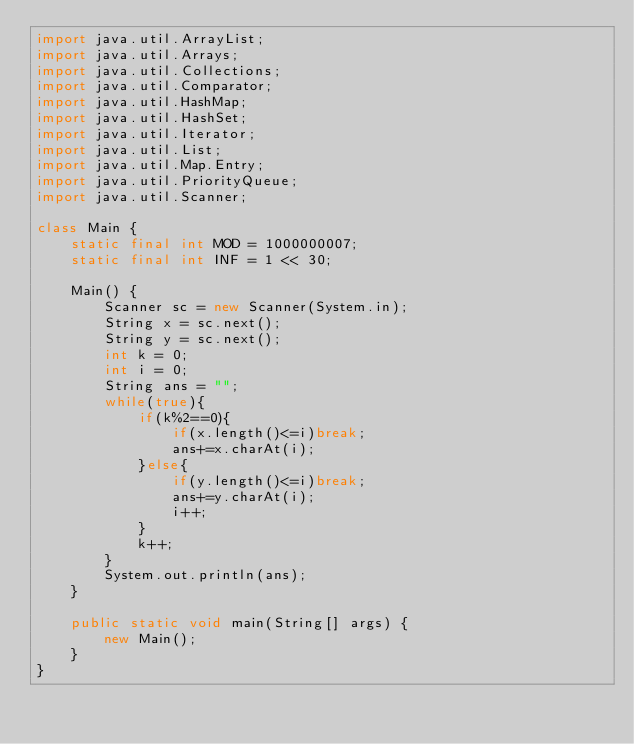Convert code to text. <code><loc_0><loc_0><loc_500><loc_500><_Java_>import java.util.ArrayList;
import java.util.Arrays;
import java.util.Collections;
import java.util.Comparator;
import java.util.HashMap;
import java.util.HashSet;
import java.util.Iterator;
import java.util.List;
import java.util.Map.Entry;
import java.util.PriorityQueue;
import java.util.Scanner;

class Main {
    static final int MOD = 1000000007;
    static final int INF = 1 << 30;

    Main() {
        Scanner sc = new Scanner(System.in);
        String x = sc.next();
        String y = sc.next();
        int k = 0;
        int i = 0;
        String ans = "";
        while(true){
            if(k%2==0){
                if(x.length()<=i)break;
                ans+=x.charAt(i);
            }else{
                if(y.length()<=i)break;
                ans+=y.charAt(i);
                i++;
            }
            k++;
        }
        System.out.println(ans);
    }

    public static void main(String[] args) {
        new Main();
    }
}
</code> 